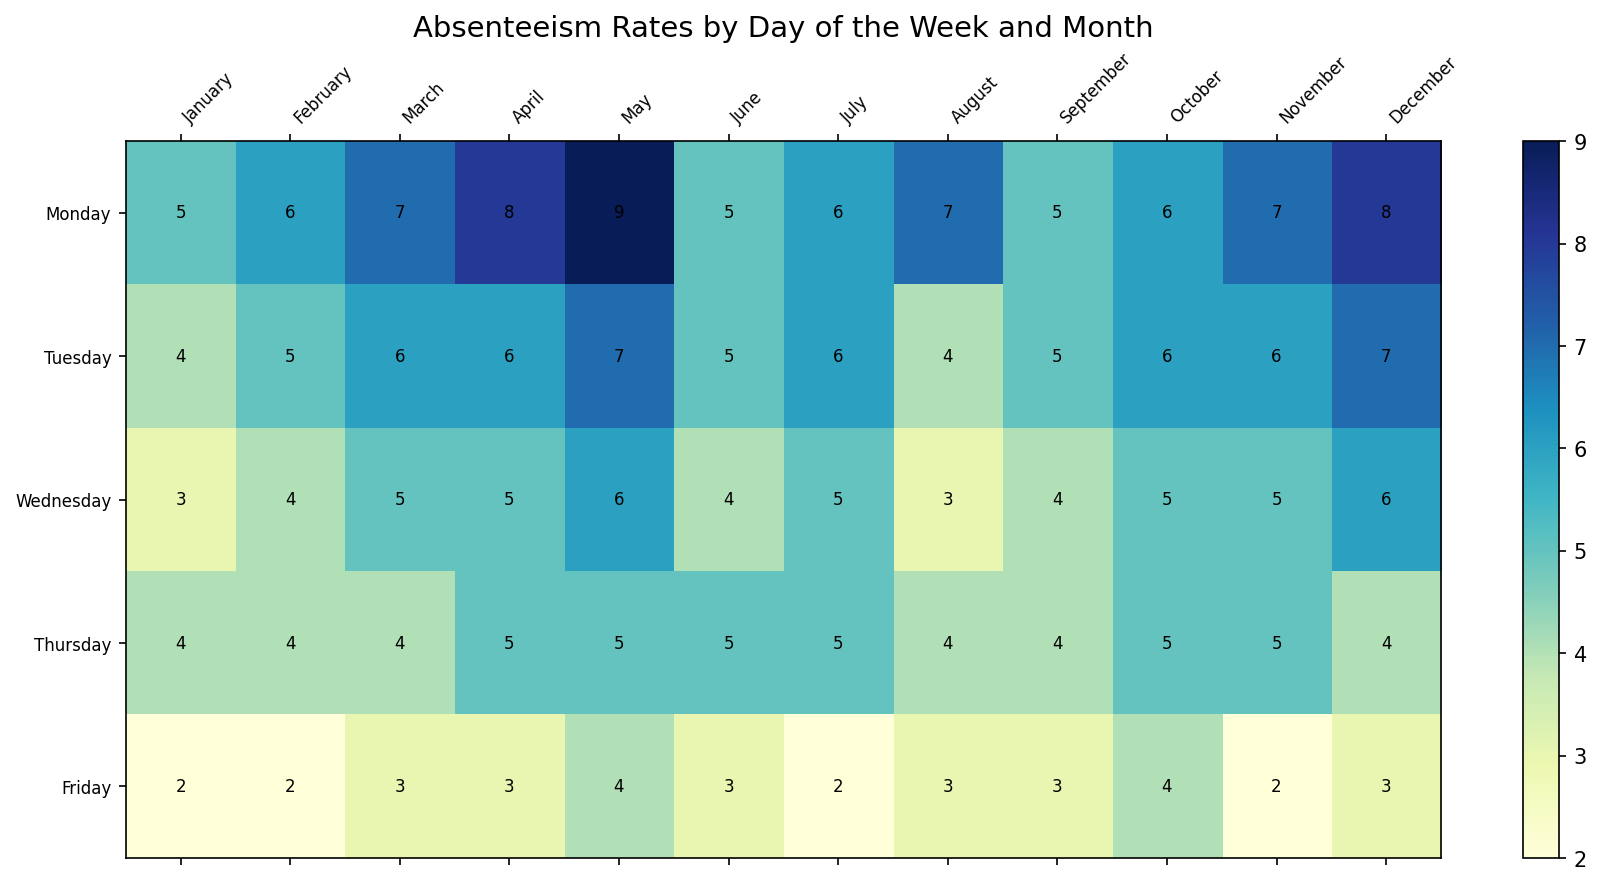What's the average absenteeism rate on Mondays throughout the year? First, gather the absenteeism rates for Mondays from January to December (5, 6, 7, 8, 9, 5, 6, 7, 5, 6, 7, 8). Then, calculate the sum of these rates: 5 + 6 + 7 + 8 + 9 + 5 + 6 + 7 + 5 + 6 + 7 + 8 = 79. Finally, divide this sum by the number of months (12) to get the average: 79 / 12 ≈ 6.58.
Answer: 6.58 Which month has the highest absenteeism rate on Tuesdays? Look at the absenteeism rates for Tuesdays across all months. The values are: 4, 5, 6, 6, 7, 5, 6, 4, 5, 6, 6, 7. The highest value among these is 7, which appears in May and December.
Answer: May and December What is the difference in absenteeism rates between the highest and lowest days in April? Look at the absenteeism rates for April: 8 (Monday), 6 (Tuesday), 5 (Wednesday), 5 (Thursday), and 3 (Friday). The highest rate is 8 (Monday) and the lowest rate is 3 (Friday). Subtract the lowest rate from the highest rate: 8 - 3 = 5.
Answer: 5 How does the absenteeism rate on Fridays in May compare to that in July? Look at the absenteeism rates on Fridays for May (4) and July (2). Compare these values: 4 (May) > 2 (July).
Answer: Higher in May 